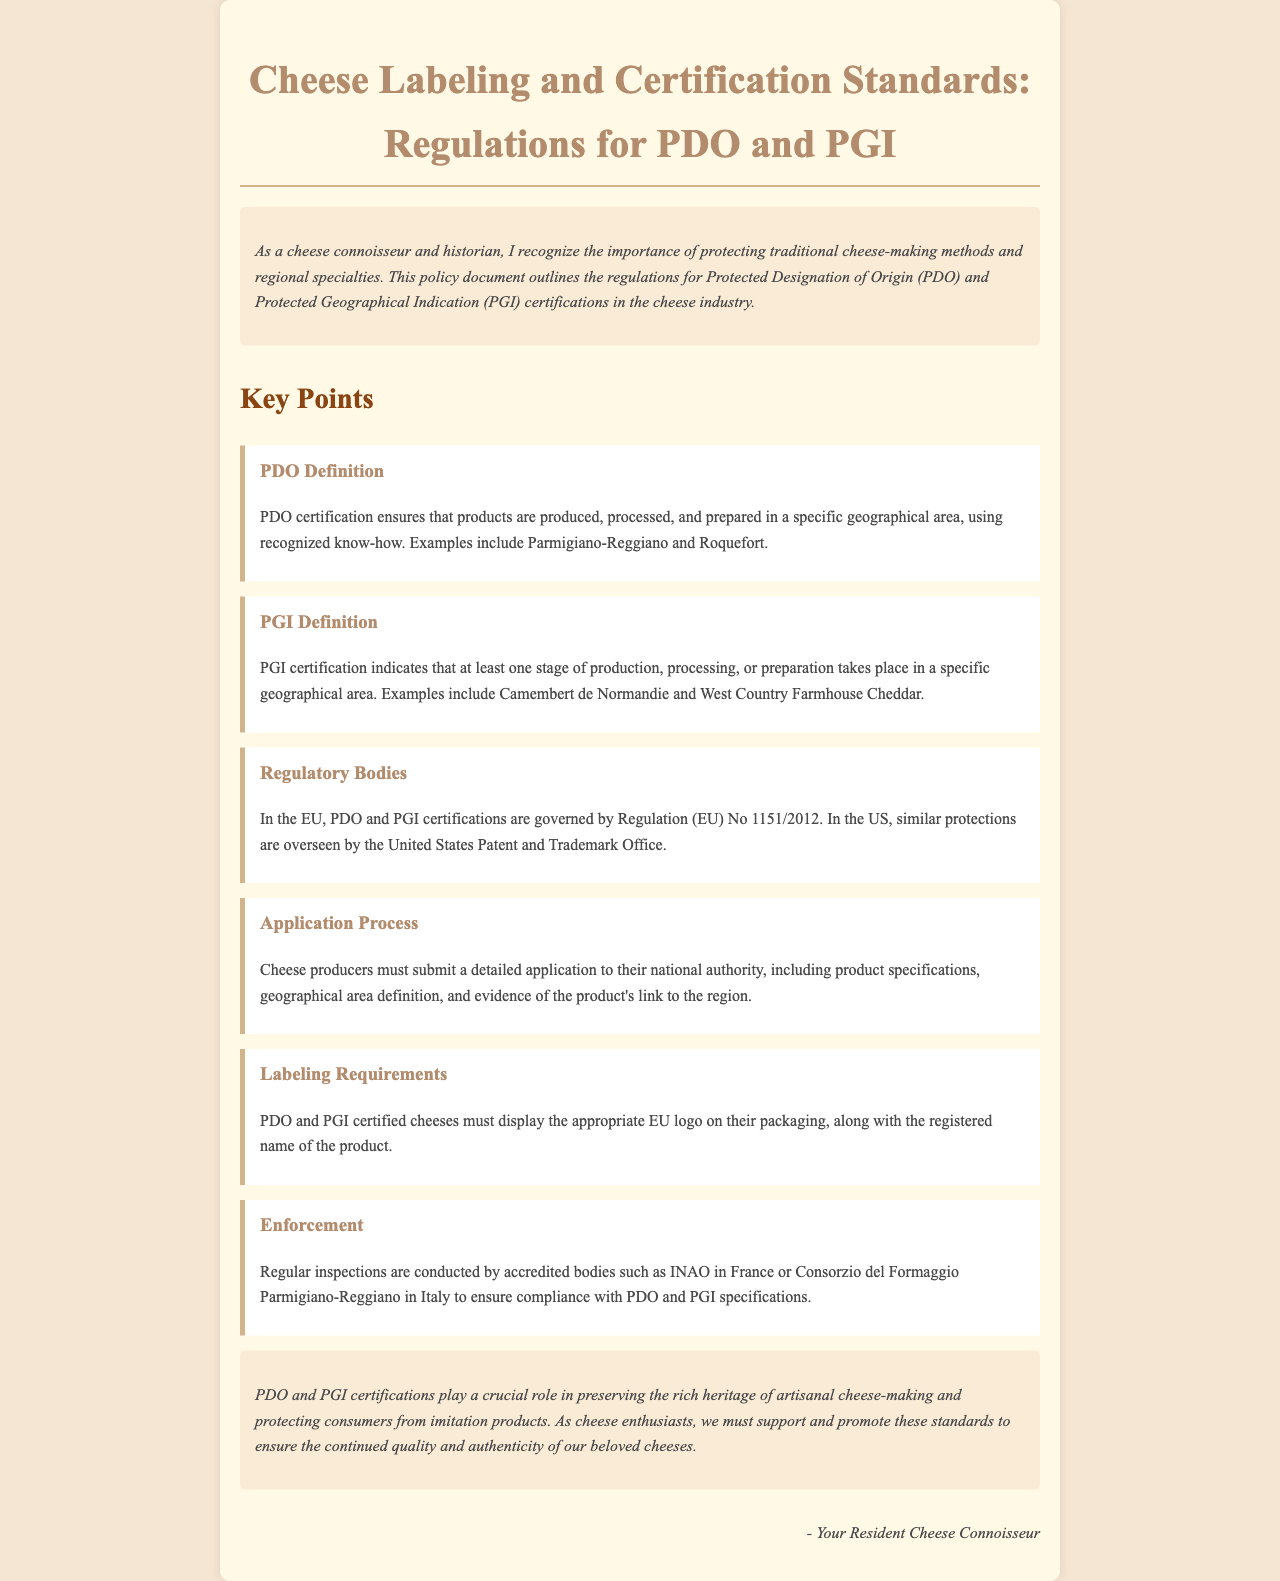What does PDO stand for? PDO is defined in the document as Protected Designation of Origin.
Answer: Protected Designation of Origin What does PGI stand for? PGI is defined in the document as Protected Geographical Indication.
Answer: Protected Geographical Indication Which regulation governs PDO and PGI certifications in the EU? The document states that PDO and PGI certifications are governed by Regulation (EU) No 1151/2012.
Answer: Regulation (EU) No 1151/2012 Name one example of a PDO certified cheese. The document provides examples of PDO certified cheeses, one being Parmigiano-Reggiano.
Answer: Parmigiano-Reggiano How must PDO and PGI certified cheeses display their certification? The document indicates that they must display the appropriate EU logo on their packaging.
Answer: EU logo What area must cheese producers submit their application to? The document specifies that cheese producers must submit their application to their national authority.
Answer: National authority Which organization conducts regular inspections in France? According to the document, the Inao conducts regular inspections in France.
Answer: INAO What is the main purpose of PDO and PGI certifications? The document states that these certifications play a crucial role in preserving the rich heritage of artisanal cheese-making.
Answer: Preserving heritage Which country oversees similar protections to PDO and PGI in the US? The document mentions that protections in the US are overseen by the United States Patent and Trademark Office.
Answer: United States Patent and Trademark Office 